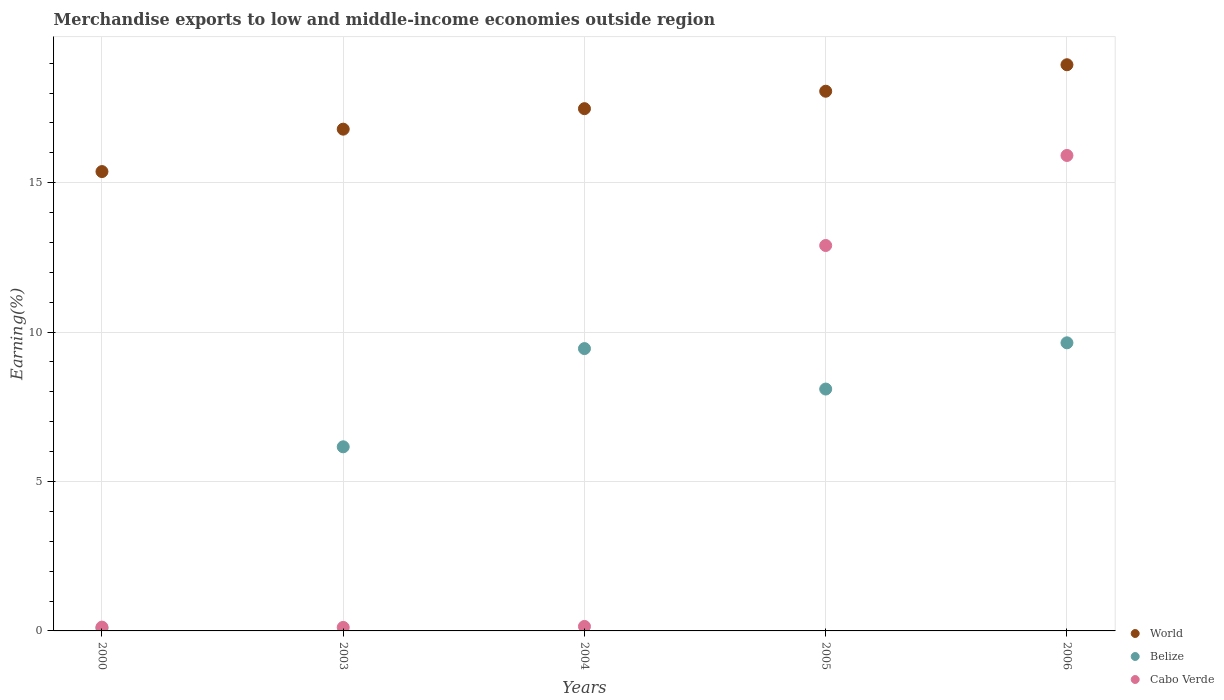Is the number of dotlines equal to the number of legend labels?
Give a very brief answer. Yes. What is the percentage of amount earned from merchandise exports in Cabo Verde in 2003?
Give a very brief answer. 0.12. Across all years, what is the maximum percentage of amount earned from merchandise exports in World?
Offer a terse response. 18.95. Across all years, what is the minimum percentage of amount earned from merchandise exports in Cabo Verde?
Provide a succinct answer. 0.12. In which year was the percentage of amount earned from merchandise exports in Belize minimum?
Offer a terse response. 2000. What is the total percentage of amount earned from merchandise exports in World in the graph?
Provide a short and direct response. 86.65. What is the difference between the percentage of amount earned from merchandise exports in Cabo Verde in 2003 and that in 2004?
Keep it short and to the point. -0.03. What is the difference between the percentage of amount earned from merchandise exports in Cabo Verde in 2006 and the percentage of amount earned from merchandise exports in Belize in 2004?
Your answer should be compact. 6.46. What is the average percentage of amount earned from merchandise exports in Belize per year?
Provide a short and direct response. 6.69. In the year 2003, what is the difference between the percentage of amount earned from merchandise exports in World and percentage of amount earned from merchandise exports in Cabo Verde?
Provide a short and direct response. 16.67. In how many years, is the percentage of amount earned from merchandise exports in Belize greater than 1 %?
Keep it short and to the point. 4. What is the ratio of the percentage of amount earned from merchandise exports in Cabo Verde in 2003 to that in 2005?
Provide a succinct answer. 0.01. Is the difference between the percentage of amount earned from merchandise exports in World in 2000 and 2005 greater than the difference between the percentage of amount earned from merchandise exports in Cabo Verde in 2000 and 2005?
Your response must be concise. Yes. What is the difference between the highest and the second highest percentage of amount earned from merchandise exports in Cabo Verde?
Give a very brief answer. 3.01. What is the difference between the highest and the lowest percentage of amount earned from merchandise exports in World?
Your answer should be compact. 3.58. In how many years, is the percentage of amount earned from merchandise exports in World greater than the average percentage of amount earned from merchandise exports in World taken over all years?
Your response must be concise. 3. Is the sum of the percentage of amount earned from merchandise exports in World in 2005 and 2006 greater than the maximum percentage of amount earned from merchandise exports in Belize across all years?
Provide a short and direct response. Yes. How many years are there in the graph?
Offer a terse response. 5. What is the title of the graph?
Your answer should be very brief. Merchandise exports to low and middle-income economies outside region. Does "Estonia" appear as one of the legend labels in the graph?
Make the answer very short. No. What is the label or title of the X-axis?
Give a very brief answer. Years. What is the label or title of the Y-axis?
Your answer should be compact. Earning(%). What is the Earning(%) of World in 2000?
Ensure brevity in your answer.  15.37. What is the Earning(%) of Belize in 2000?
Make the answer very short. 0.1. What is the Earning(%) of Cabo Verde in 2000?
Your response must be concise. 0.13. What is the Earning(%) of World in 2003?
Provide a short and direct response. 16.79. What is the Earning(%) in Belize in 2003?
Provide a short and direct response. 6.16. What is the Earning(%) in Cabo Verde in 2003?
Keep it short and to the point. 0.12. What is the Earning(%) in World in 2004?
Keep it short and to the point. 17.48. What is the Earning(%) in Belize in 2004?
Ensure brevity in your answer.  9.45. What is the Earning(%) of Cabo Verde in 2004?
Offer a terse response. 0.15. What is the Earning(%) of World in 2005?
Provide a short and direct response. 18.06. What is the Earning(%) of Belize in 2005?
Your response must be concise. 8.09. What is the Earning(%) of Cabo Verde in 2005?
Provide a short and direct response. 12.9. What is the Earning(%) in World in 2006?
Provide a succinct answer. 18.95. What is the Earning(%) in Belize in 2006?
Ensure brevity in your answer.  9.64. What is the Earning(%) in Cabo Verde in 2006?
Provide a succinct answer. 15.91. Across all years, what is the maximum Earning(%) in World?
Offer a terse response. 18.95. Across all years, what is the maximum Earning(%) of Belize?
Provide a short and direct response. 9.64. Across all years, what is the maximum Earning(%) in Cabo Verde?
Provide a short and direct response. 15.91. Across all years, what is the minimum Earning(%) in World?
Provide a succinct answer. 15.37. Across all years, what is the minimum Earning(%) of Belize?
Provide a succinct answer. 0.1. Across all years, what is the minimum Earning(%) of Cabo Verde?
Your response must be concise. 0.12. What is the total Earning(%) in World in the graph?
Make the answer very short. 86.65. What is the total Earning(%) of Belize in the graph?
Offer a terse response. 33.44. What is the total Earning(%) in Cabo Verde in the graph?
Provide a succinct answer. 29.2. What is the difference between the Earning(%) of World in 2000 and that in 2003?
Keep it short and to the point. -1.42. What is the difference between the Earning(%) of Belize in 2000 and that in 2003?
Offer a terse response. -6.07. What is the difference between the Earning(%) in Cabo Verde in 2000 and that in 2003?
Give a very brief answer. 0.01. What is the difference between the Earning(%) in World in 2000 and that in 2004?
Make the answer very short. -2.11. What is the difference between the Earning(%) of Belize in 2000 and that in 2004?
Make the answer very short. -9.35. What is the difference between the Earning(%) of Cabo Verde in 2000 and that in 2004?
Provide a succinct answer. -0.02. What is the difference between the Earning(%) of World in 2000 and that in 2005?
Give a very brief answer. -2.69. What is the difference between the Earning(%) in Belize in 2000 and that in 2005?
Your answer should be very brief. -8. What is the difference between the Earning(%) in Cabo Verde in 2000 and that in 2005?
Your answer should be very brief. -12.77. What is the difference between the Earning(%) in World in 2000 and that in 2006?
Your answer should be compact. -3.58. What is the difference between the Earning(%) in Belize in 2000 and that in 2006?
Keep it short and to the point. -9.55. What is the difference between the Earning(%) in Cabo Verde in 2000 and that in 2006?
Your answer should be very brief. -15.78. What is the difference between the Earning(%) in World in 2003 and that in 2004?
Offer a terse response. -0.69. What is the difference between the Earning(%) in Belize in 2003 and that in 2004?
Ensure brevity in your answer.  -3.29. What is the difference between the Earning(%) in Cabo Verde in 2003 and that in 2004?
Provide a succinct answer. -0.03. What is the difference between the Earning(%) of World in 2003 and that in 2005?
Offer a very short reply. -1.27. What is the difference between the Earning(%) in Belize in 2003 and that in 2005?
Provide a short and direct response. -1.93. What is the difference between the Earning(%) in Cabo Verde in 2003 and that in 2005?
Provide a succinct answer. -12.78. What is the difference between the Earning(%) of World in 2003 and that in 2006?
Provide a short and direct response. -2.16. What is the difference between the Earning(%) of Belize in 2003 and that in 2006?
Provide a short and direct response. -3.48. What is the difference between the Earning(%) of Cabo Verde in 2003 and that in 2006?
Your answer should be compact. -15.79. What is the difference between the Earning(%) of World in 2004 and that in 2005?
Keep it short and to the point. -0.58. What is the difference between the Earning(%) of Belize in 2004 and that in 2005?
Make the answer very short. 1.35. What is the difference between the Earning(%) of Cabo Verde in 2004 and that in 2005?
Your answer should be compact. -12.75. What is the difference between the Earning(%) of World in 2004 and that in 2006?
Make the answer very short. -1.47. What is the difference between the Earning(%) of Belize in 2004 and that in 2006?
Offer a very short reply. -0.19. What is the difference between the Earning(%) in Cabo Verde in 2004 and that in 2006?
Your response must be concise. -15.76. What is the difference between the Earning(%) of World in 2005 and that in 2006?
Provide a short and direct response. -0.89. What is the difference between the Earning(%) of Belize in 2005 and that in 2006?
Give a very brief answer. -1.55. What is the difference between the Earning(%) in Cabo Verde in 2005 and that in 2006?
Give a very brief answer. -3.01. What is the difference between the Earning(%) in World in 2000 and the Earning(%) in Belize in 2003?
Give a very brief answer. 9.21. What is the difference between the Earning(%) in World in 2000 and the Earning(%) in Cabo Verde in 2003?
Ensure brevity in your answer.  15.25. What is the difference between the Earning(%) in Belize in 2000 and the Earning(%) in Cabo Verde in 2003?
Make the answer very short. -0.02. What is the difference between the Earning(%) of World in 2000 and the Earning(%) of Belize in 2004?
Your answer should be very brief. 5.92. What is the difference between the Earning(%) of World in 2000 and the Earning(%) of Cabo Verde in 2004?
Give a very brief answer. 15.22. What is the difference between the Earning(%) of Belize in 2000 and the Earning(%) of Cabo Verde in 2004?
Give a very brief answer. -0.05. What is the difference between the Earning(%) in World in 2000 and the Earning(%) in Belize in 2005?
Your answer should be compact. 7.28. What is the difference between the Earning(%) in World in 2000 and the Earning(%) in Cabo Verde in 2005?
Offer a very short reply. 2.47. What is the difference between the Earning(%) of Belize in 2000 and the Earning(%) of Cabo Verde in 2005?
Provide a short and direct response. -12.8. What is the difference between the Earning(%) in World in 2000 and the Earning(%) in Belize in 2006?
Ensure brevity in your answer.  5.73. What is the difference between the Earning(%) in World in 2000 and the Earning(%) in Cabo Verde in 2006?
Your answer should be compact. -0.54. What is the difference between the Earning(%) of Belize in 2000 and the Earning(%) of Cabo Verde in 2006?
Give a very brief answer. -15.82. What is the difference between the Earning(%) of World in 2003 and the Earning(%) of Belize in 2004?
Keep it short and to the point. 7.34. What is the difference between the Earning(%) of World in 2003 and the Earning(%) of Cabo Verde in 2004?
Offer a very short reply. 16.64. What is the difference between the Earning(%) of Belize in 2003 and the Earning(%) of Cabo Verde in 2004?
Offer a terse response. 6.01. What is the difference between the Earning(%) in World in 2003 and the Earning(%) in Belize in 2005?
Your answer should be very brief. 8.7. What is the difference between the Earning(%) of World in 2003 and the Earning(%) of Cabo Verde in 2005?
Give a very brief answer. 3.89. What is the difference between the Earning(%) in Belize in 2003 and the Earning(%) in Cabo Verde in 2005?
Offer a very short reply. -6.74. What is the difference between the Earning(%) in World in 2003 and the Earning(%) in Belize in 2006?
Ensure brevity in your answer.  7.15. What is the difference between the Earning(%) in World in 2003 and the Earning(%) in Cabo Verde in 2006?
Offer a very short reply. 0.88. What is the difference between the Earning(%) of Belize in 2003 and the Earning(%) of Cabo Verde in 2006?
Provide a short and direct response. -9.75. What is the difference between the Earning(%) of World in 2004 and the Earning(%) of Belize in 2005?
Provide a short and direct response. 9.38. What is the difference between the Earning(%) in World in 2004 and the Earning(%) in Cabo Verde in 2005?
Provide a succinct answer. 4.58. What is the difference between the Earning(%) of Belize in 2004 and the Earning(%) of Cabo Verde in 2005?
Your answer should be very brief. -3.45. What is the difference between the Earning(%) in World in 2004 and the Earning(%) in Belize in 2006?
Ensure brevity in your answer.  7.84. What is the difference between the Earning(%) in World in 2004 and the Earning(%) in Cabo Verde in 2006?
Offer a very short reply. 1.57. What is the difference between the Earning(%) of Belize in 2004 and the Earning(%) of Cabo Verde in 2006?
Ensure brevity in your answer.  -6.46. What is the difference between the Earning(%) in World in 2005 and the Earning(%) in Belize in 2006?
Your answer should be compact. 8.42. What is the difference between the Earning(%) in World in 2005 and the Earning(%) in Cabo Verde in 2006?
Your answer should be very brief. 2.15. What is the difference between the Earning(%) of Belize in 2005 and the Earning(%) of Cabo Verde in 2006?
Provide a succinct answer. -7.82. What is the average Earning(%) of World per year?
Your answer should be very brief. 17.33. What is the average Earning(%) in Belize per year?
Give a very brief answer. 6.69. What is the average Earning(%) in Cabo Verde per year?
Your response must be concise. 5.84. In the year 2000, what is the difference between the Earning(%) in World and Earning(%) in Belize?
Offer a terse response. 15.28. In the year 2000, what is the difference between the Earning(%) of World and Earning(%) of Cabo Verde?
Your answer should be compact. 15.24. In the year 2000, what is the difference between the Earning(%) in Belize and Earning(%) in Cabo Verde?
Keep it short and to the point. -0.03. In the year 2003, what is the difference between the Earning(%) of World and Earning(%) of Belize?
Keep it short and to the point. 10.63. In the year 2003, what is the difference between the Earning(%) in World and Earning(%) in Cabo Verde?
Ensure brevity in your answer.  16.67. In the year 2003, what is the difference between the Earning(%) of Belize and Earning(%) of Cabo Verde?
Provide a short and direct response. 6.04. In the year 2004, what is the difference between the Earning(%) in World and Earning(%) in Belize?
Ensure brevity in your answer.  8.03. In the year 2004, what is the difference between the Earning(%) of World and Earning(%) of Cabo Verde?
Give a very brief answer. 17.33. In the year 2004, what is the difference between the Earning(%) of Belize and Earning(%) of Cabo Verde?
Provide a succinct answer. 9.3. In the year 2005, what is the difference between the Earning(%) of World and Earning(%) of Belize?
Provide a succinct answer. 9.97. In the year 2005, what is the difference between the Earning(%) in World and Earning(%) in Cabo Verde?
Your answer should be compact. 5.16. In the year 2005, what is the difference between the Earning(%) in Belize and Earning(%) in Cabo Verde?
Make the answer very short. -4.8. In the year 2006, what is the difference between the Earning(%) of World and Earning(%) of Belize?
Your answer should be compact. 9.31. In the year 2006, what is the difference between the Earning(%) of World and Earning(%) of Cabo Verde?
Give a very brief answer. 3.04. In the year 2006, what is the difference between the Earning(%) of Belize and Earning(%) of Cabo Verde?
Your answer should be very brief. -6.27. What is the ratio of the Earning(%) of World in 2000 to that in 2003?
Keep it short and to the point. 0.92. What is the ratio of the Earning(%) of Belize in 2000 to that in 2003?
Offer a very short reply. 0.02. What is the ratio of the Earning(%) in Cabo Verde in 2000 to that in 2003?
Offer a very short reply. 1.08. What is the ratio of the Earning(%) in World in 2000 to that in 2004?
Your answer should be very brief. 0.88. What is the ratio of the Earning(%) in Belize in 2000 to that in 2004?
Your answer should be compact. 0.01. What is the ratio of the Earning(%) of Cabo Verde in 2000 to that in 2004?
Give a very brief answer. 0.85. What is the ratio of the Earning(%) in World in 2000 to that in 2005?
Keep it short and to the point. 0.85. What is the ratio of the Earning(%) of Belize in 2000 to that in 2005?
Your response must be concise. 0.01. What is the ratio of the Earning(%) in Cabo Verde in 2000 to that in 2005?
Your answer should be very brief. 0.01. What is the ratio of the Earning(%) of World in 2000 to that in 2006?
Your answer should be very brief. 0.81. What is the ratio of the Earning(%) of Belize in 2000 to that in 2006?
Your response must be concise. 0.01. What is the ratio of the Earning(%) in Cabo Verde in 2000 to that in 2006?
Offer a very short reply. 0.01. What is the ratio of the Earning(%) in World in 2003 to that in 2004?
Your answer should be very brief. 0.96. What is the ratio of the Earning(%) of Belize in 2003 to that in 2004?
Ensure brevity in your answer.  0.65. What is the ratio of the Earning(%) of Cabo Verde in 2003 to that in 2004?
Keep it short and to the point. 0.78. What is the ratio of the Earning(%) in World in 2003 to that in 2005?
Make the answer very short. 0.93. What is the ratio of the Earning(%) in Belize in 2003 to that in 2005?
Your answer should be compact. 0.76. What is the ratio of the Earning(%) in Cabo Verde in 2003 to that in 2005?
Provide a succinct answer. 0.01. What is the ratio of the Earning(%) of World in 2003 to that in 2006?
Your answer should be compact. 0.89. What is the ratio of the Earning(%) in Belize in 2003 to that in 2006?
Make the answer very short. 0.64. What is the ratio of the Earning(%) in Cabo Verde in 2003 to that in 2006?
Provide a short and direct response. 0.01. What is the ratio of the Earning(%) in Belize in 2004 to that in 2005?
Ensure brevity in your answer.  1.17. What is the ratio of the Earning(%) of Cabo Verde in 2004 to that in 2005?
Offer a very short reply. 0.01. What is the ratio of the Earning(%) of World in 2004 to that in 2006?
Offer a terse response. 0.92. What is the ratio of the Earning(%) of Cabo Verde in 2004 to that in 2006?
Your answer should be very brief. 0.01. What is the ratio of the Earning(%) of World in 2005 to that in 2006?
Ensure brevity in your answer.  0.95. What is the ratio of the Earning(%) in Belize in 2005 to that in 2006?
Provide a short and direct response. 0.84. What is the ratio of the Earning(%) of Cabo Verde in 2005 to that in 2006?
Your answer should be compact. 0.81. What is the difference between the highest and the second highest Earning(%) in World?
Offer a very short reply. 0.89. What is the difference between the highest and the second highest Earning(%) of Belize?
Make the answer very short. 0.19. What is the difference between the highest and the second highest Earning(%) in Cabo Verde?
Keep it short and to the point. 3.01. What is the difference between the highest and the lowest Earning(%) of World?
Provide a short and direct response. 3.58. What is the difference between the highest and the lowest Earning(%) of Belize?
Provide a short and direct response. 9.55. What is the difference between the highest and the lowest Earning(%) of Cabo Verde?
Provide a short and direct response. 15.79. 